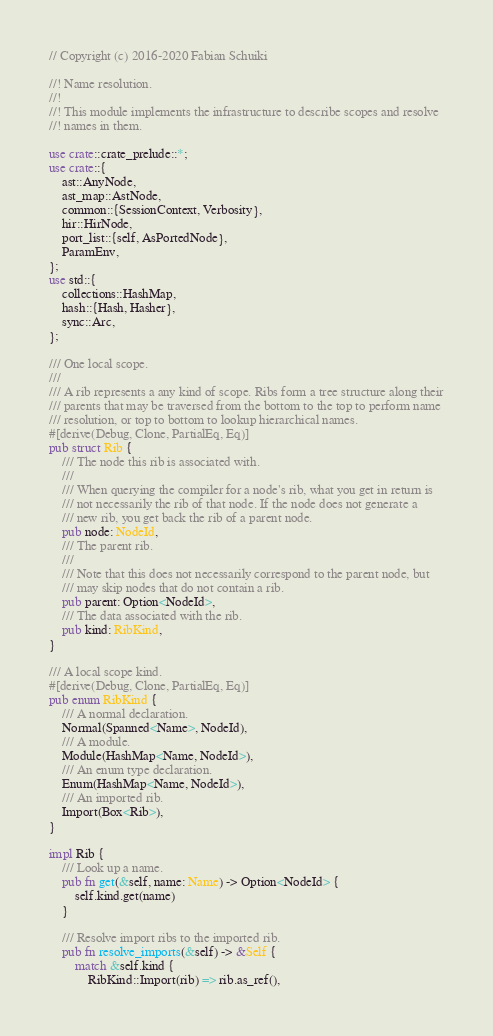<code> <loc_0><loc_0><loc_500><loc_500><_Rust_>// Copyright (c) 2016-2020 Fabian Schuiki

//! Name resolution.
//!
//! This module implements the infrastructure to describe scopes and resolve
//! names in them.

use crate::crate_prelude::*;
use crate::{
    ast::AnyNode,
    ast_map::AstNode,
    common::{SessionContext, Verbosity},
    hir::HirNode,
    port_list::{self, AsPortedNode},
    ParamEnv,
};
use std::{
    collections::HashMap,
    hash::{Hash, Hasher},
    sync::Arc,
};

/// One local scope.
///
/// A rib represents a any kind of scope. Ribs form a tree structure along their
/// parents that may be traversed from the bottom to the top to perform name
/// resolution, or top to bottom to lookup hierarchical names.
#[derive(Debug, Clone, PartialEq, Eq)]
pub struct Rib {
    /// The node this rib is associated with.
    ///
    /// When querying the compiler for a node's rib, what you get in return is
    /// not necessarily the rib of that node. If the node does not generate a
    /// new rib, you get back the rib of a parent node.
    pub node: NodeId,
    /// The parent rib.
    ///
    /// Note that this does not necessarily correspond to the parent node, but
    /// may skip nodes that do not contain a rib.
    pub parent: Option<NodeId>,
    /// The data associated with the rib.
    pub kind: RibKind,
}

/// A local scope kind.
#[derive(Debug, Clone, PartialEq, Eq)]
pub enum RibKind {
    /// A normal declaration.
    Normal(Spanned<Name>, NodeId),
    /// A module.
    Module(HashMap<Name, NodeId>),
    /// An enum type declaration.
    Enum(HashMap<Name, NodeId>),
    /// An imported rib.
    Import(Box<Rib>),
}

impl Rib {
    /// Look up a name.
    pub fn get(&self, name: Name) -> Option<NodeId> {
        self.kind.get(name)
    }

    /// Resolve import ribs to the imported rib.
    pub fn resolve_imports(&self) -> &Self {
        match &self.kind {
            RibKind::Import(rib) => rib.as_ref(),</code> 